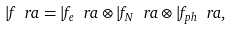Convert formula to latex. <formula><loc_0><loc_0><loc_500><loc_500>| f \ r a = | f _ { e } \ r a \otimes | f _ { N } \ r a \otimes | f _ { p h } \ r a ,</formula> 